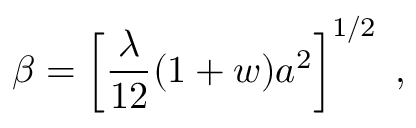<formula> <loc_0><loc_0><loc_500><loc_500>\beta = \left [ \frac { \lambda } { 1 2 } ( 1 + w ) a ^ { 2 } \right ] ^ { 1 / 2 } \, ,</formula> 